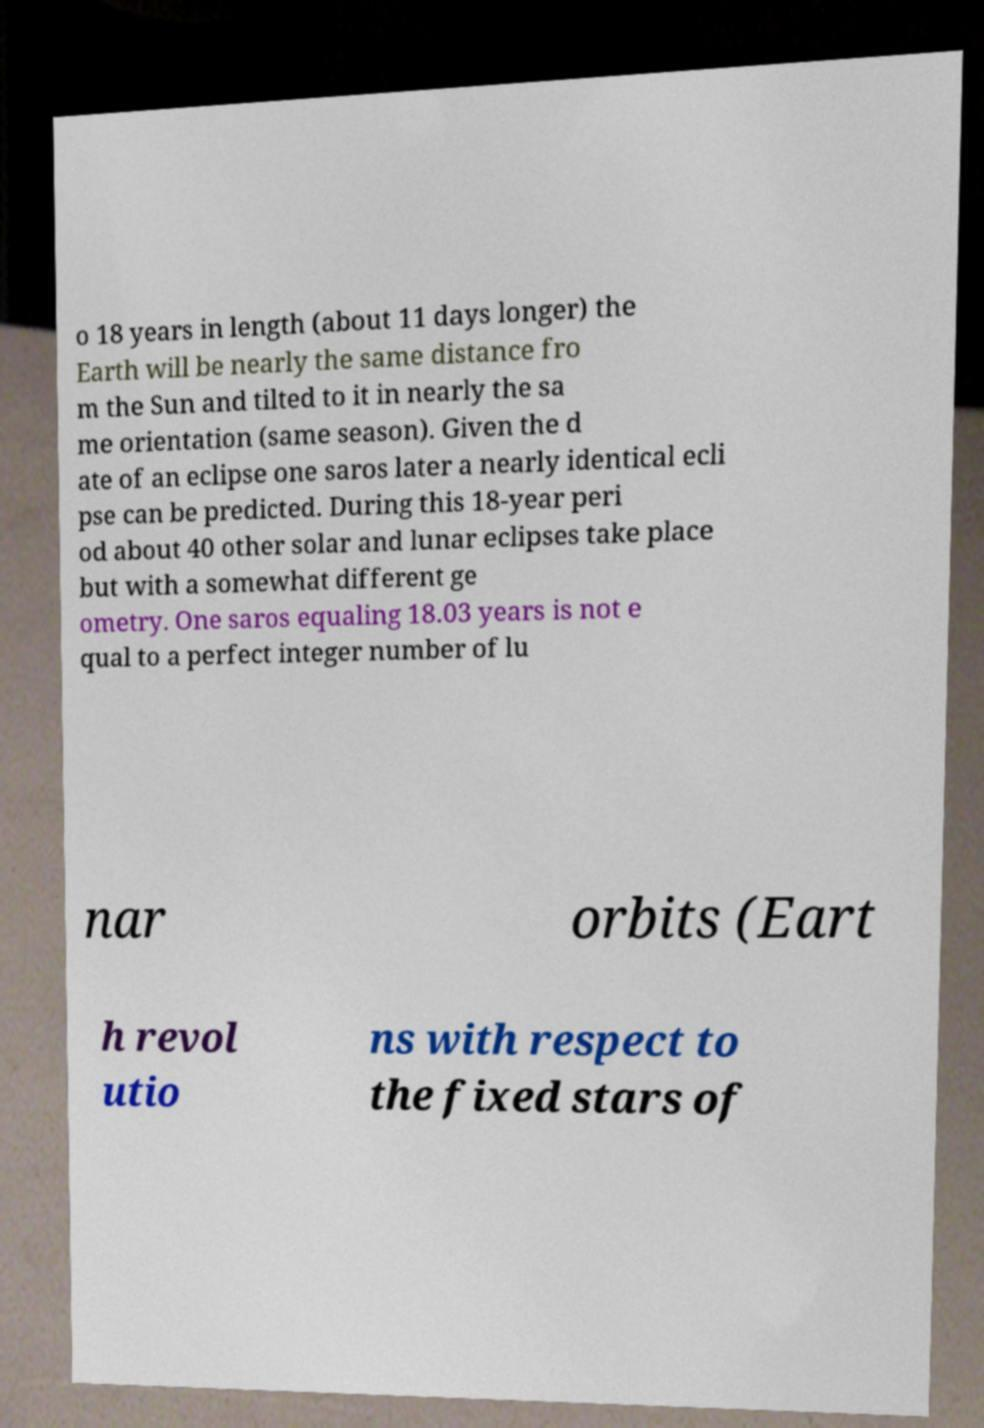Please identify and transcribe the text found in this image. o 18 years in length (about 11 days longer) the Earth will be nearly the same distance fro m the Sun and tilted to it in nearly the sa me orientation (same season). Given the d ate of an eclipse one saros later a nearly identical ecli pse can be predicted. During this 18-year peri od about 40 other solar and lunar eclipses take place but with a somewhat different ge ometry. One saros equaling 18.03 years is not e qual to a perfect integer number of lu nar orbits (Eart h revol utio ns with respect to the fixed stars of 